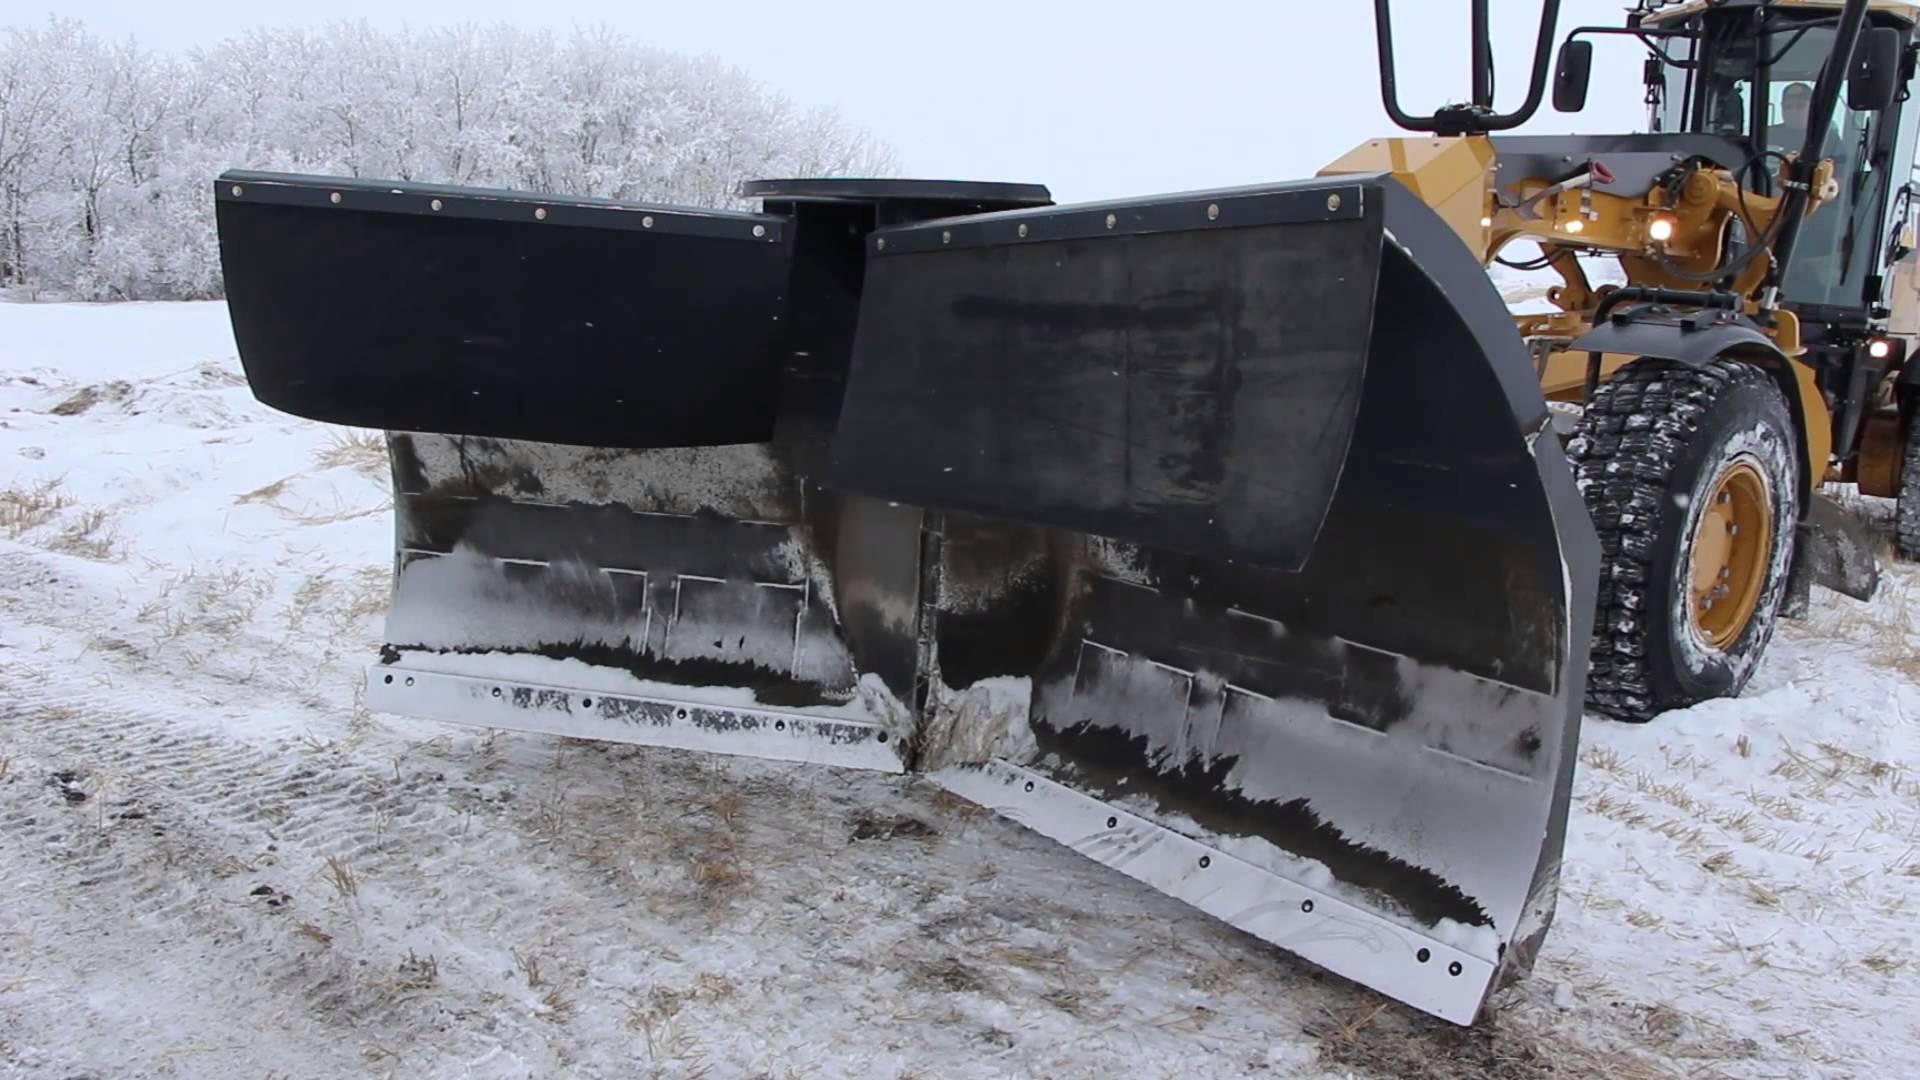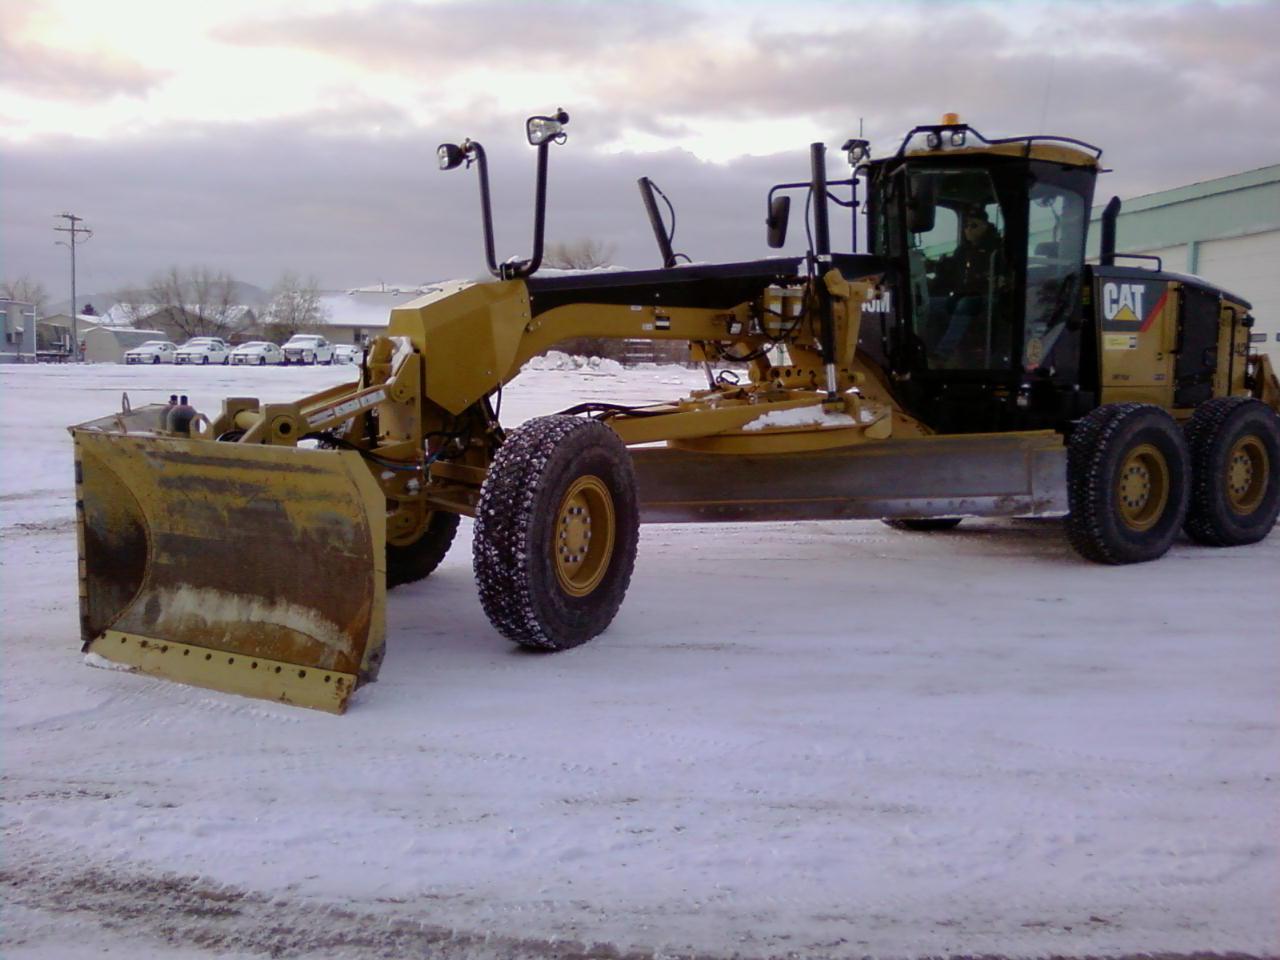The first image is the image on the left, the second image is the image on the right. Evaluate the accuracy of this statement regarding the images: "Right image shows at least one yellow tractor with plow on a dirt ground without snow.". Is it true? Answer yes or no. No. 